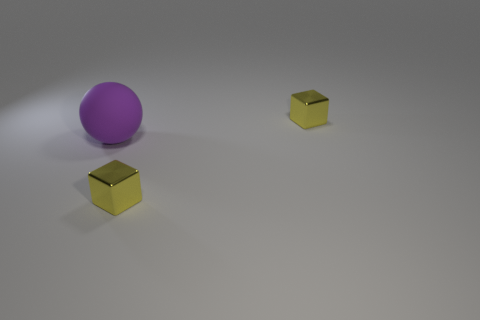Add 2 gray balls. How many objects exist? 5 Subtract all cubes. How many objects are left? 1 Subtract all cyan cubes. Subtract all cyan spheres. How many cubes are left? 2 Subtract all cyan blocks. How many gray balls are left? 0 Subtract all small purple metal objects. Subtract all matte balls. How many objects are left? 2 Add 2 purple rubber balls. How many purple rubber balls are left? 3 Add 3 purple matte things. How many purple matte things exist? 4 Subtract 2 yellow cubes. How many objects are left? 1 